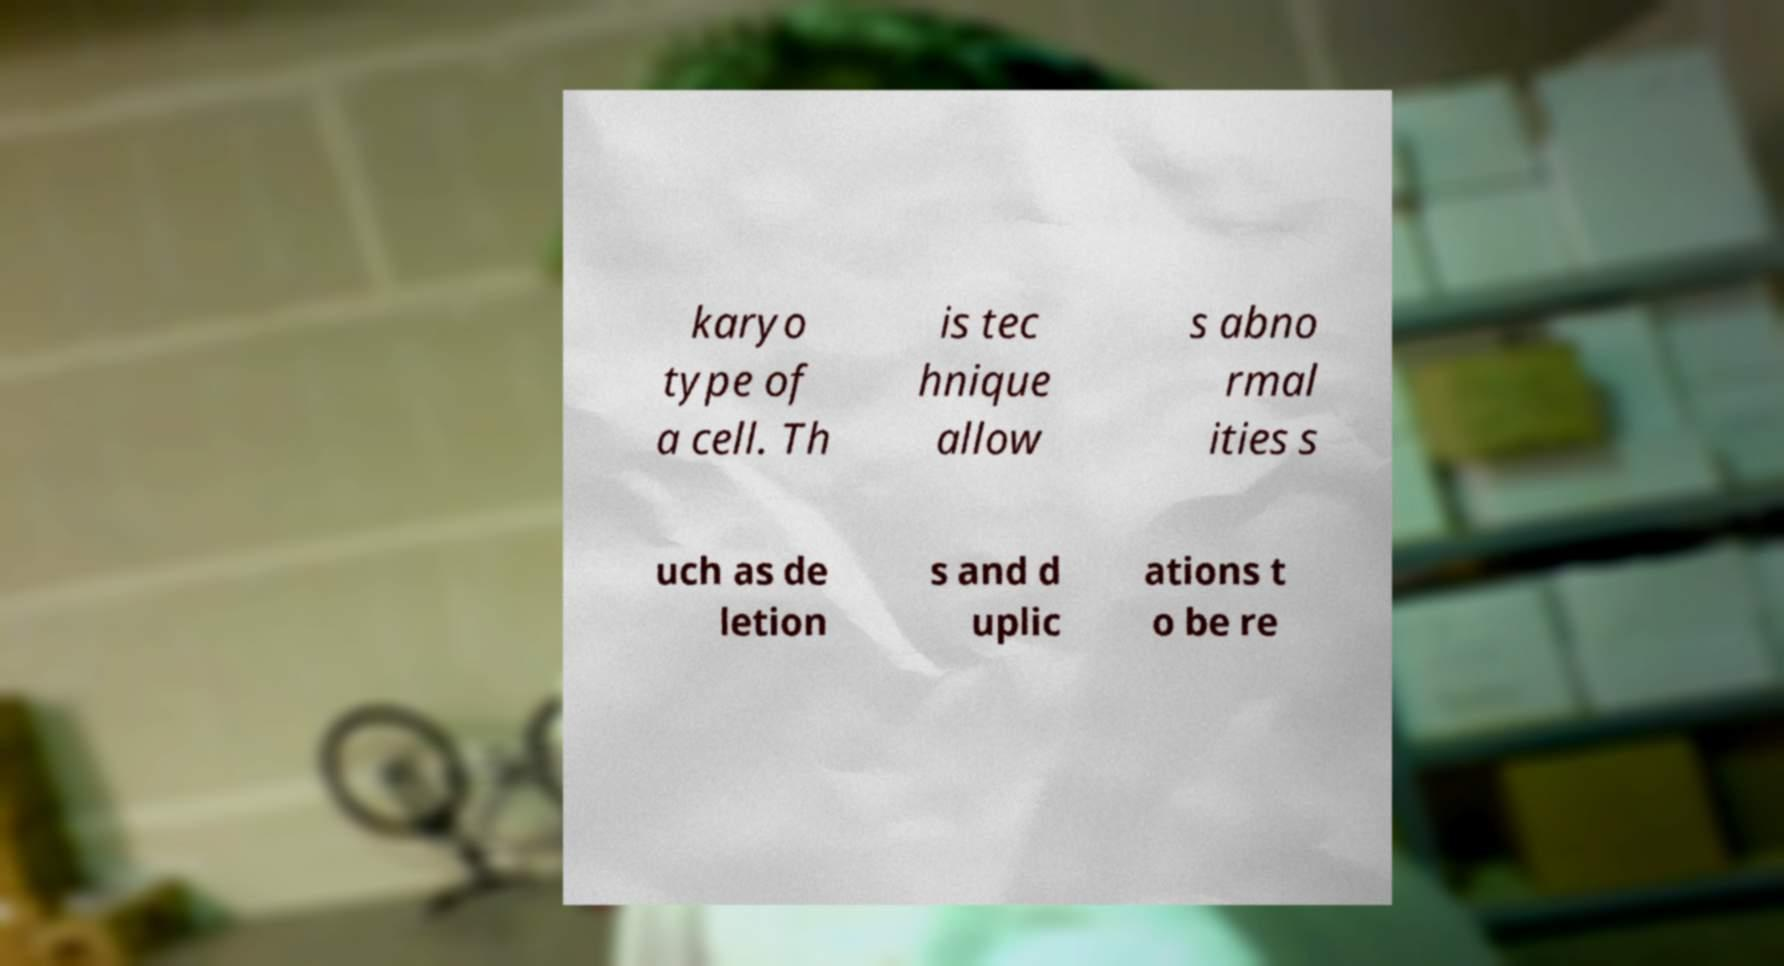Could you extract and type out the text from this image? karyo type of a cell. Th is tec hnique allow s abno rmal ities s uch as de letion s and d uplic ations t o be re 